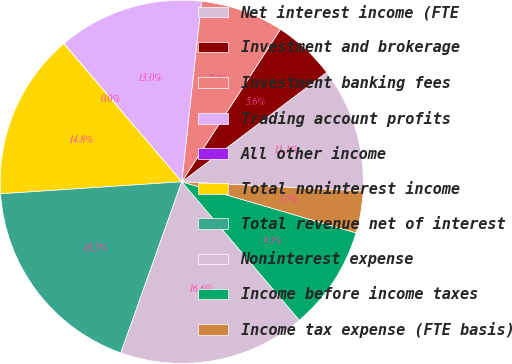Convert chart to OTSL. <chart><loc_0><loc_0><loc_500><loc_500><pie_chart><fcel>Net interest income (FTE<fcel>Investment and brokerage<fcel>Investment banking fees<fcel>Trading account profits<fcel>All other income<fcel>Total noninterest income<fcel>Total revenue net of interest<fcel>Noninterest expense<fcel>Income before income taxes<fcel>Income tax expense (FTE basis)<nl><fcel>11.11%<fcel>5.57%<fcel>7.41%<fcel>12.96%<fcel>0.03%<fcel>14.8%<fcel>18.5%<fcel>16.65%<fcel>9.26%<fcel>3.72%<nl></chart> 